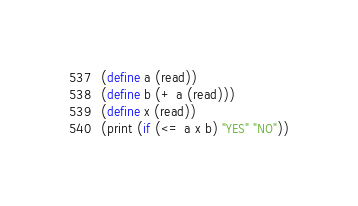Convert code to text. <code><loc_0><loc_0><loc_500><loc_500><_Scheme_>(define a (read))
(define b (+ a (read)))
(define x (read))
(print (if (<= a x b) "YES" "NO"))</code> 